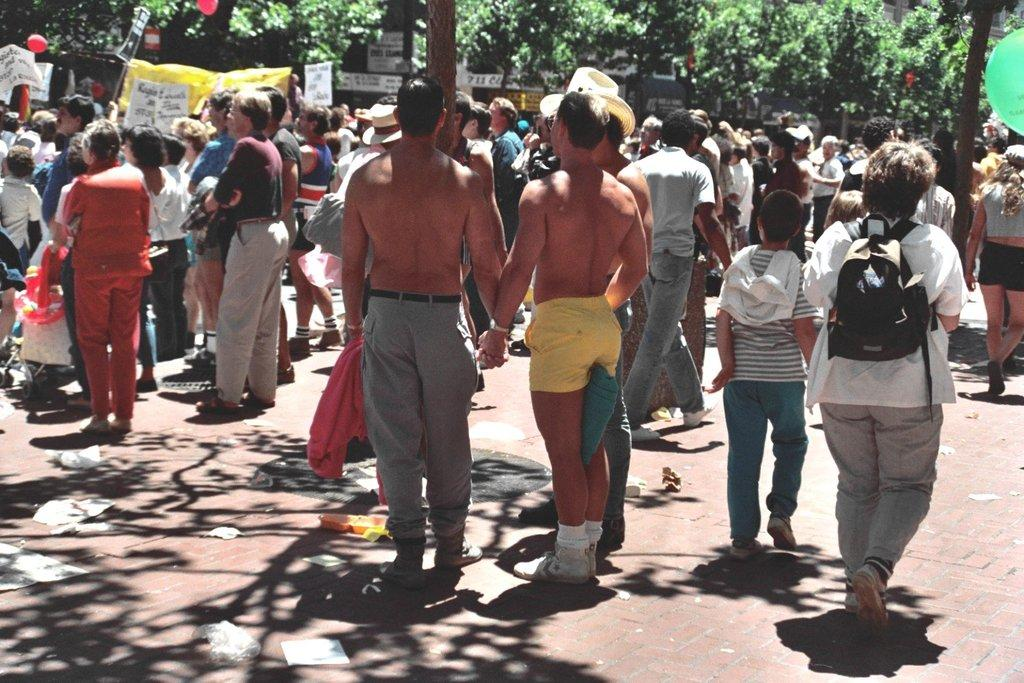How many people are in the group visible in the image? The number of people in the group cannot be determined definitively from the provided facts. What can be seen in the background of the image? There are posters, boards, and trees in the background of the image. What type of nail is being used to solve the arithmetic problem on the square board in the image? There is no nail, arithmetic problem, or square board present in the image. 